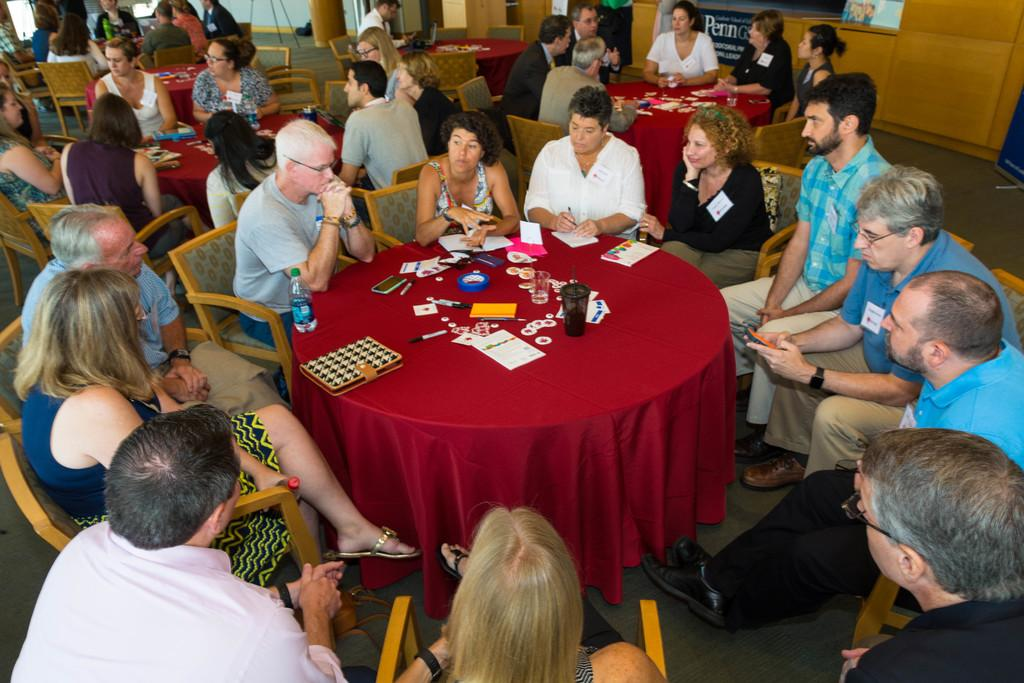How many people are in the image? There is a group of people in the image. What are the people doing in the image? The people are sitting on a chair and engaged in a discussion. What is the topic of the discussion? The discussion is about something important. What type of produce is being selected by the people in the image? There is no produce present in the image; the people are engaged in a discussion while sitting on a chair. 